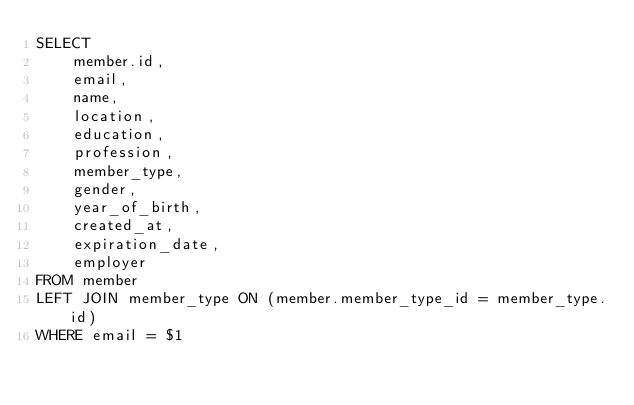<code> <loc_0><loc_0><loc_500><loc_500><_SQL_>SELECT
    member.id,
    email,
    name,
    location,
    education,
    profession,
    member_type,
    gender,
    year_of_birth,
    created_at,
    expiration_date,
    employer
FROM member
LEFT JOIN member_type ON (member.member_type_id = member_type.id)
WHERE email = $1
</code> 